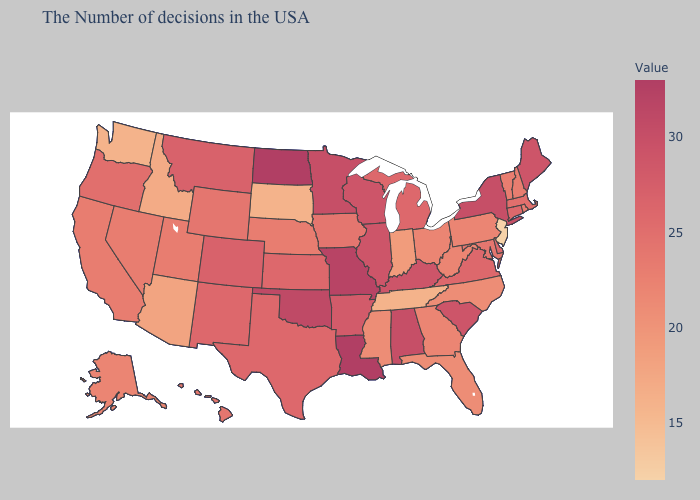Does Idaho have the highest value in the USA?
Short answer required. No. Among the states that border North Carolina , does Tennessee have the highest value?
Be succinct. No. Does Arizona have the lowest value in the West?
Keep it brief. No. Which states hav the highest value in the MidWest?
Concise answer only. North Dakota. 